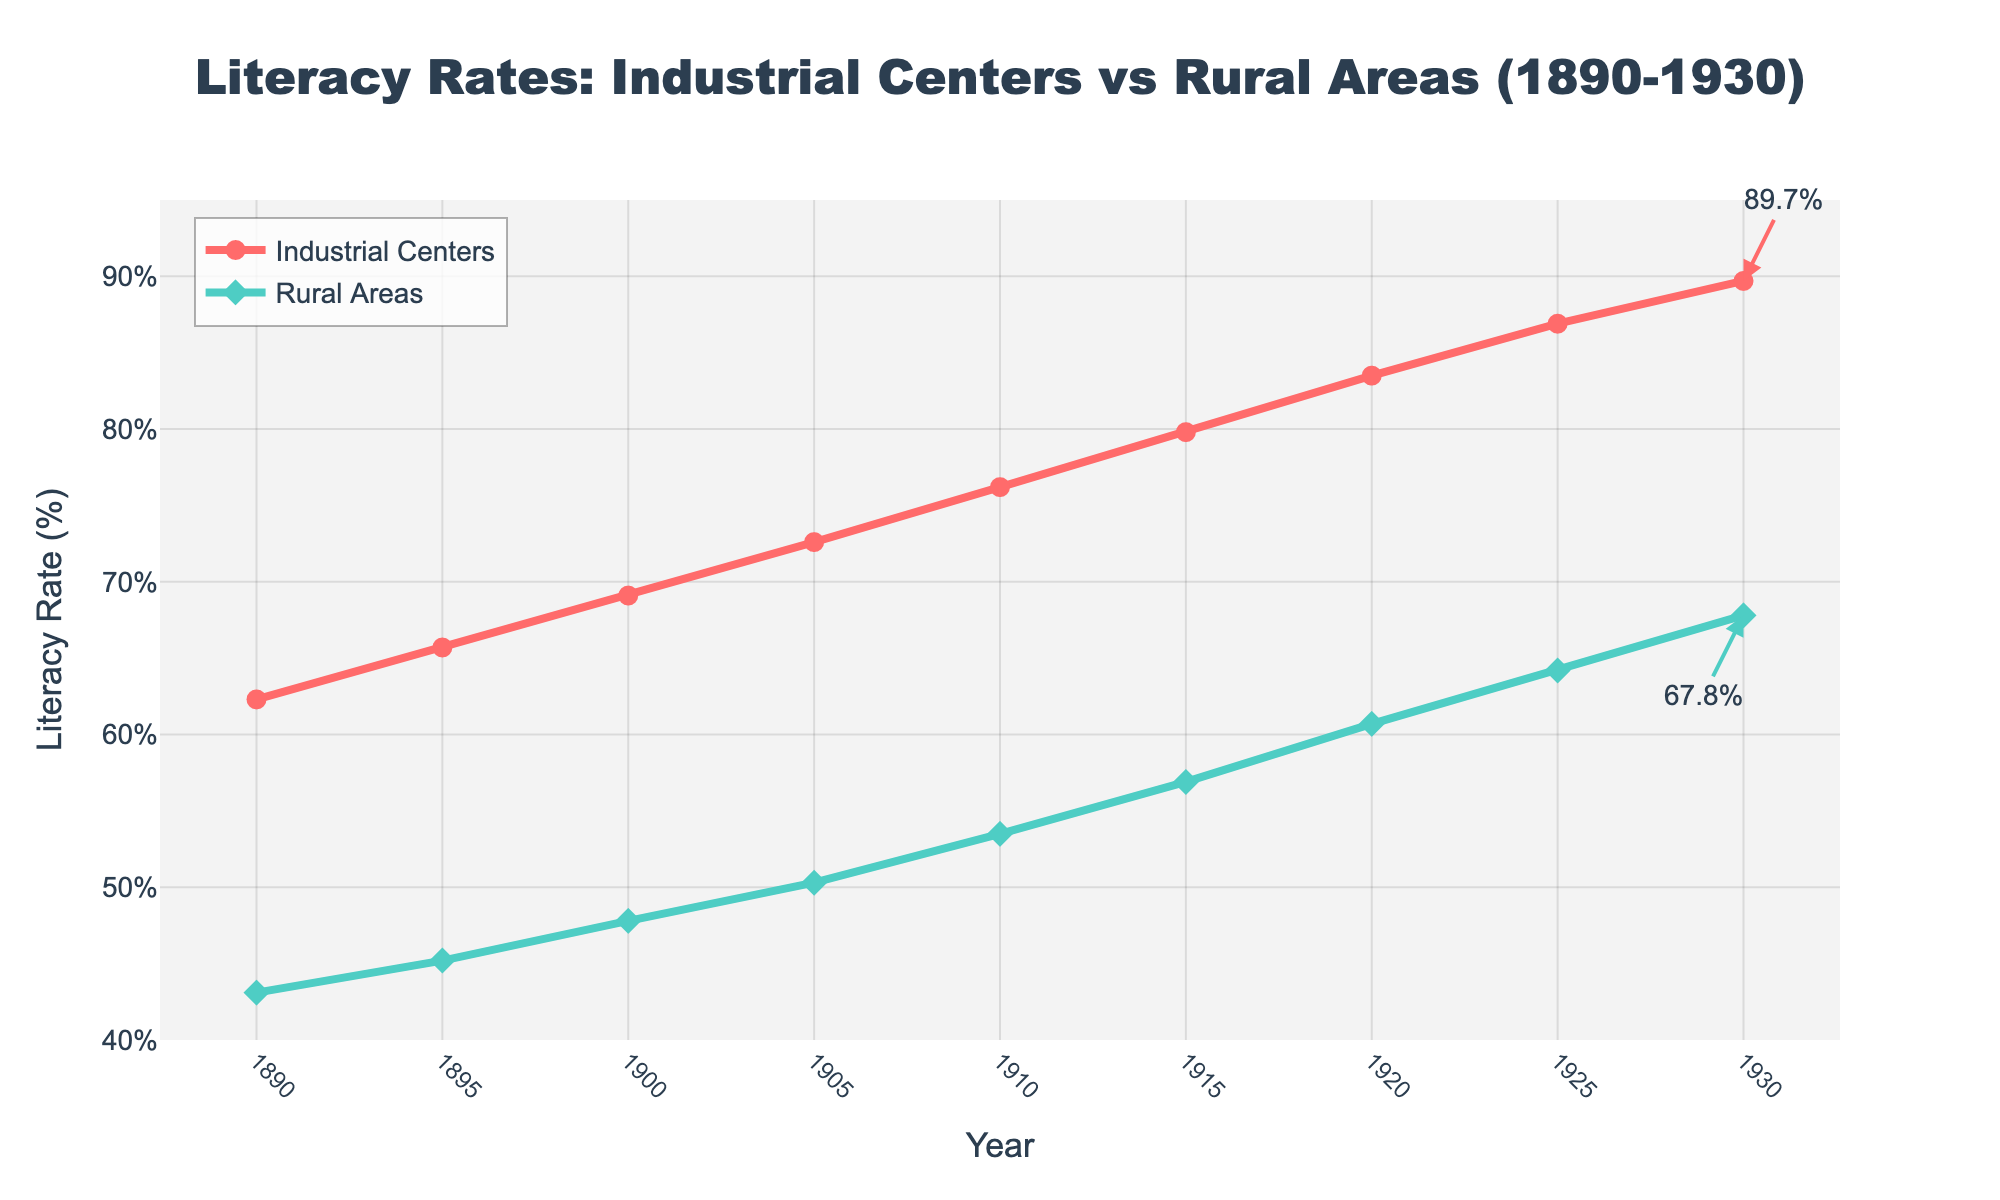What is the overall trend in literacy rates in industrial centers from 1890 to 1930? The literacy rate in industrial centers consistently increased each year from 62.3% in 1890 to 89.7% in 1930. This can be observed by following the upward progression of the red line and the markers on the chart.
Answer: It increased How does the literacy rate in rural areas in 1900 compare to that in 1930? The literacy rate in rural areas in 1900 was 47.8%, and it increased to 67.8% in 1930. To compare, subtract the 1900 value from the 1930 value: 67.8% - 47.8% = 20%.
Answer: It increased by 20% Which area had a higher literacy rate in 1915, and by how much? In 1915, the literacy rate in industrial centers was 79.8%, whereas in rural areas it was 56.9%. To find the difference, subtract the rural rate from the industrial rate: 79.8% - 56.9% = 22.9%.
Answer: Industrial centers by 22.9% How did the literacy rates in industrial centers and rural areas change from 1925 to 1930? In 1925, the literacy rate in industrial centers was 86.9% and rose to 89.7% by 1930, an increase of 2.8%. For rural areas, the rate was 64.2% in 1925 and increased to 67.8% in 1930, an increase of 3.6%.
Answer: Both increased, industrial centers by 2.8%, rural areas by 3.6% What is the average literacy rate in rural areas over the entire period (1890-1930)? To find the average literacy rate in rural areas, sum the rates for all years and divide by the number of years: (43.1 + 45.2 + 47.8 + 50.3 + 53.5 + 56.9 + 60.7 + 64.2 + 67.8) / 9 = 487.5 / 9 ≈ 54.2%.
Answer: Approximately 54.2% What year did industrial centers first surpass a literacy rate of 70%? The literacy rate in industrial centers first surpassed 70% in 1905, when it reached 72.6%. This can be observed by locating the point where the red line crosses the 70% mark.
Answer: 1905 By how many percentage points did the literacy rate in industrial centers increase from 1890 to 1910? In 1890, the literacy rate in industrial centers was 62.3%, and by 1910 it was 76.2%. The increase is calculated by subtracting the 1890 rate from the 1910 rate: 76.2% - 62.3% = 13.9%.
Answer: 13.9% Which area saw a greater increase in literacy rate from 1895 to 1905, and by how much? From 1895 to 1905, the literacy rate in industrial centers increased from 65.7% to 72.6%, an increase of 6.9%. In rural areas, it increased from 45.2% to 50.3%, an increase of 5.1%. The industrial centers saw a greater increase by 6.9% - 5.1% = 1.8%.
Answer: Industrial centers by 1.8% What is the difference in literacy rate between industrial centers and rural areas in 1930? In 1930, the literacy rate in industrial centers was 89.7%, whereas in rural areas it was 67.8%. The difference is 89.7% - 67.8% = 21.9%.
Answer: 21.9% During which decade did rural areas experience the highest increase in literacy rate? The highest increase for rural areas can be calculated per decade: from 1890 to 1900: 47.8% - 43.1% = 4.7%; 1900 to 1910: 53.5% - 47.8% = 5.7%; 1910 to 1920: 60.7% - 53.5% = 7.2%; 1920 to 1930: 67.8% - 60.7% = 7.1%. The highest increase was during the 1910 to 1920 period with 7.2%.
Answer: 1910 to 1920 